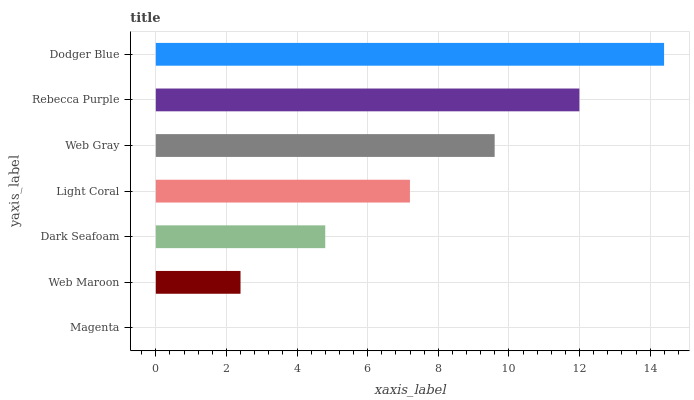Is Magenta the minimum?
Answer yes or no. Yes. Is Dodger Blue the maximum?
Answer yes or no. Yes. Is Web Maroon the minimum?
Answer yes or no. No. Is Web Maroon the maximum?
Answer yes or no. No. Is Web Maroon greater than Magenta?
Answer yes or no. Yes. Is Magenta less than Web Maroon?
Answer yes or no. Yes. Is Magenta greater than Web Maroon?
Answer yes or no. No. Is Web Maroon less than Magenta?
Answer yes or no. No. Is Light Coral the high median?
Answer yes or no. Yes. Is Light Coral the low median?
Answer yes or no. Yes. Is Web Gray the high median?
Answer yes or no. No. Is Rebecca Purple the low median?
Answer yes or no. No. 